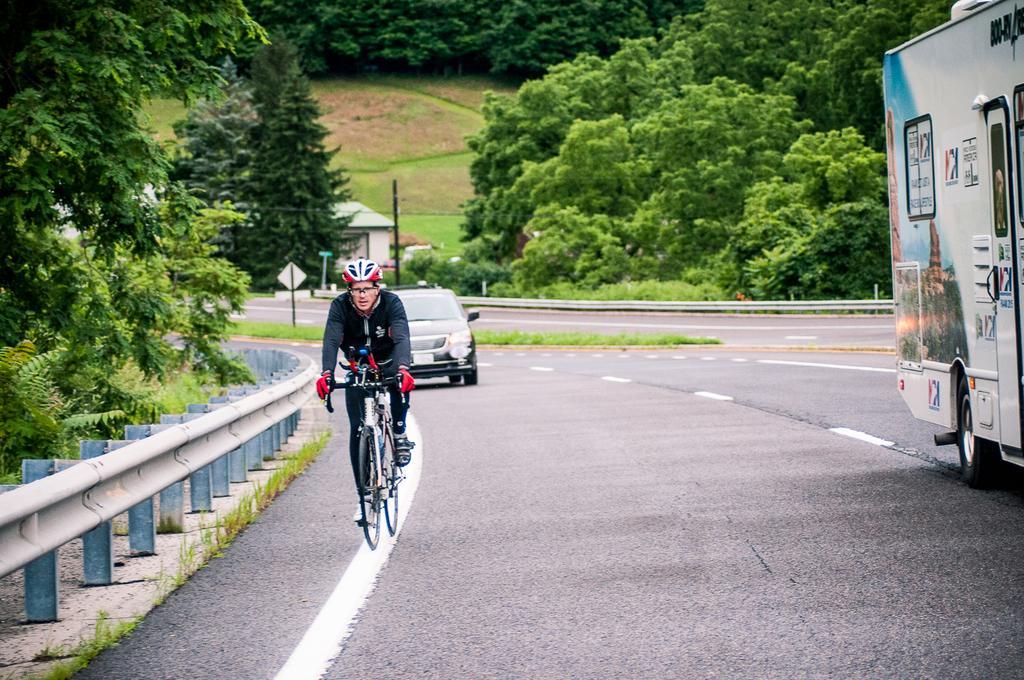In one or two sentences, can you explain what this image depicts? This is an outside view. On the right side there is a truck on the road. One person is riding a bicycle, in the background there is a car. On the left side of the road there is a railing and there are few trees. In the background there are few poles, trees and also I can see a house. 